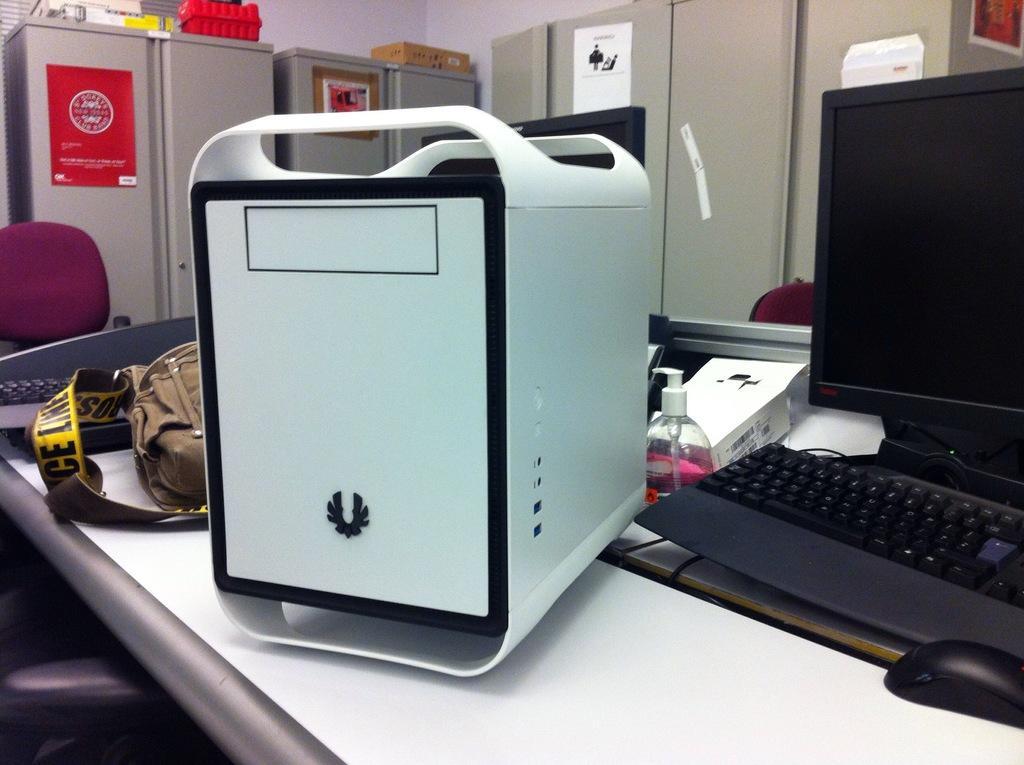Please provide a concise description of this image. In the foreground I can see a table on which laptop, keyboard, bottle, bag, machine and so on is there. In the background I can see cupboards, boxes, chair and a wall. This image is taken may be in a room. 